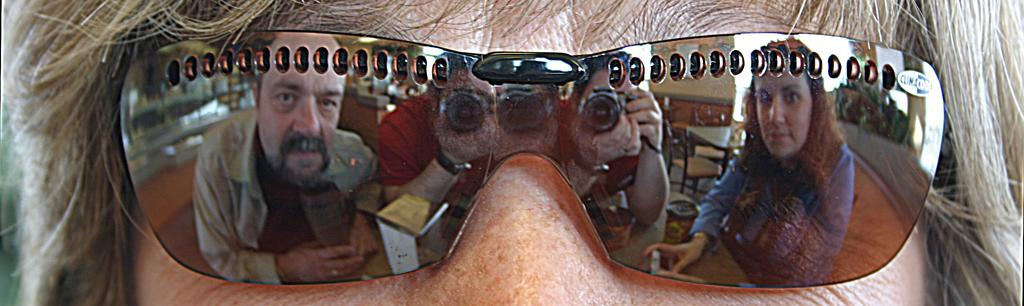What is the main subject of the image? There is a human face in the image. What is the human face wearing? The human face is wearing goggles. What can be seen in the reflection on the goggles? There is a reflection of a man and a woman on the goggles. Who is capturing the picture? There is a man capturing the picture with a camera. What type of iron can be seen in the image? There is no iron present in the image. How many quinces are visible in the image? There are no quinces present in the image. 